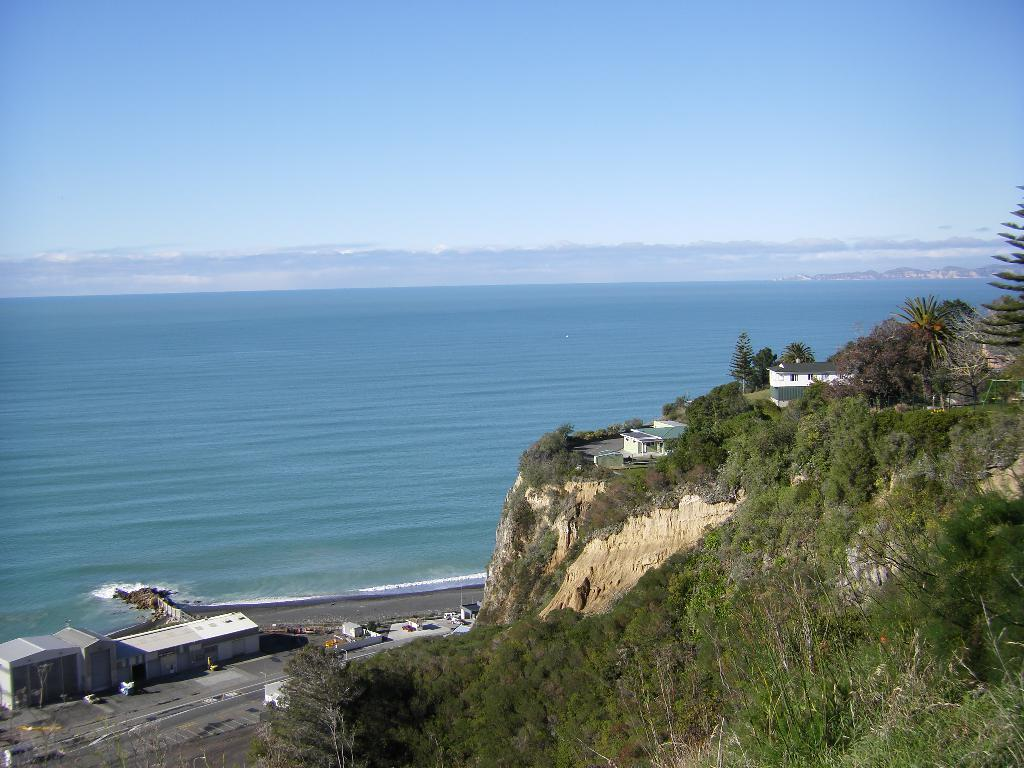Where are the houses located in the image? There are houses on a mountain and near a road in the image. What else can be seen in the image besides the houses? Vehicles, water, trees, and plants are present in the image. What is visible in the sky in the image? There are clouds in the sky in the image. What type of collar can be seen on the dog in the image? There is no dog or collar present in the image. How does the image depict the act of saying good-bye? The image does not depict any act of saying good-bye; it shows houses, vehicles, water, trees, plants, and clouds. 